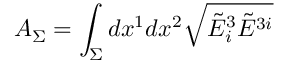Convert formula to latex. <formula><loc_0><loc_0><loc_500><loc_500>A _ { \Sigma } = \int _ { \Sigma } d x ^ { 1 } d x ^ { 2 } { \sqrt { { \tilde { E } } _ { i } ^ { 3 } { \tilde { E } } ^ { 3 i } } }</formula> 